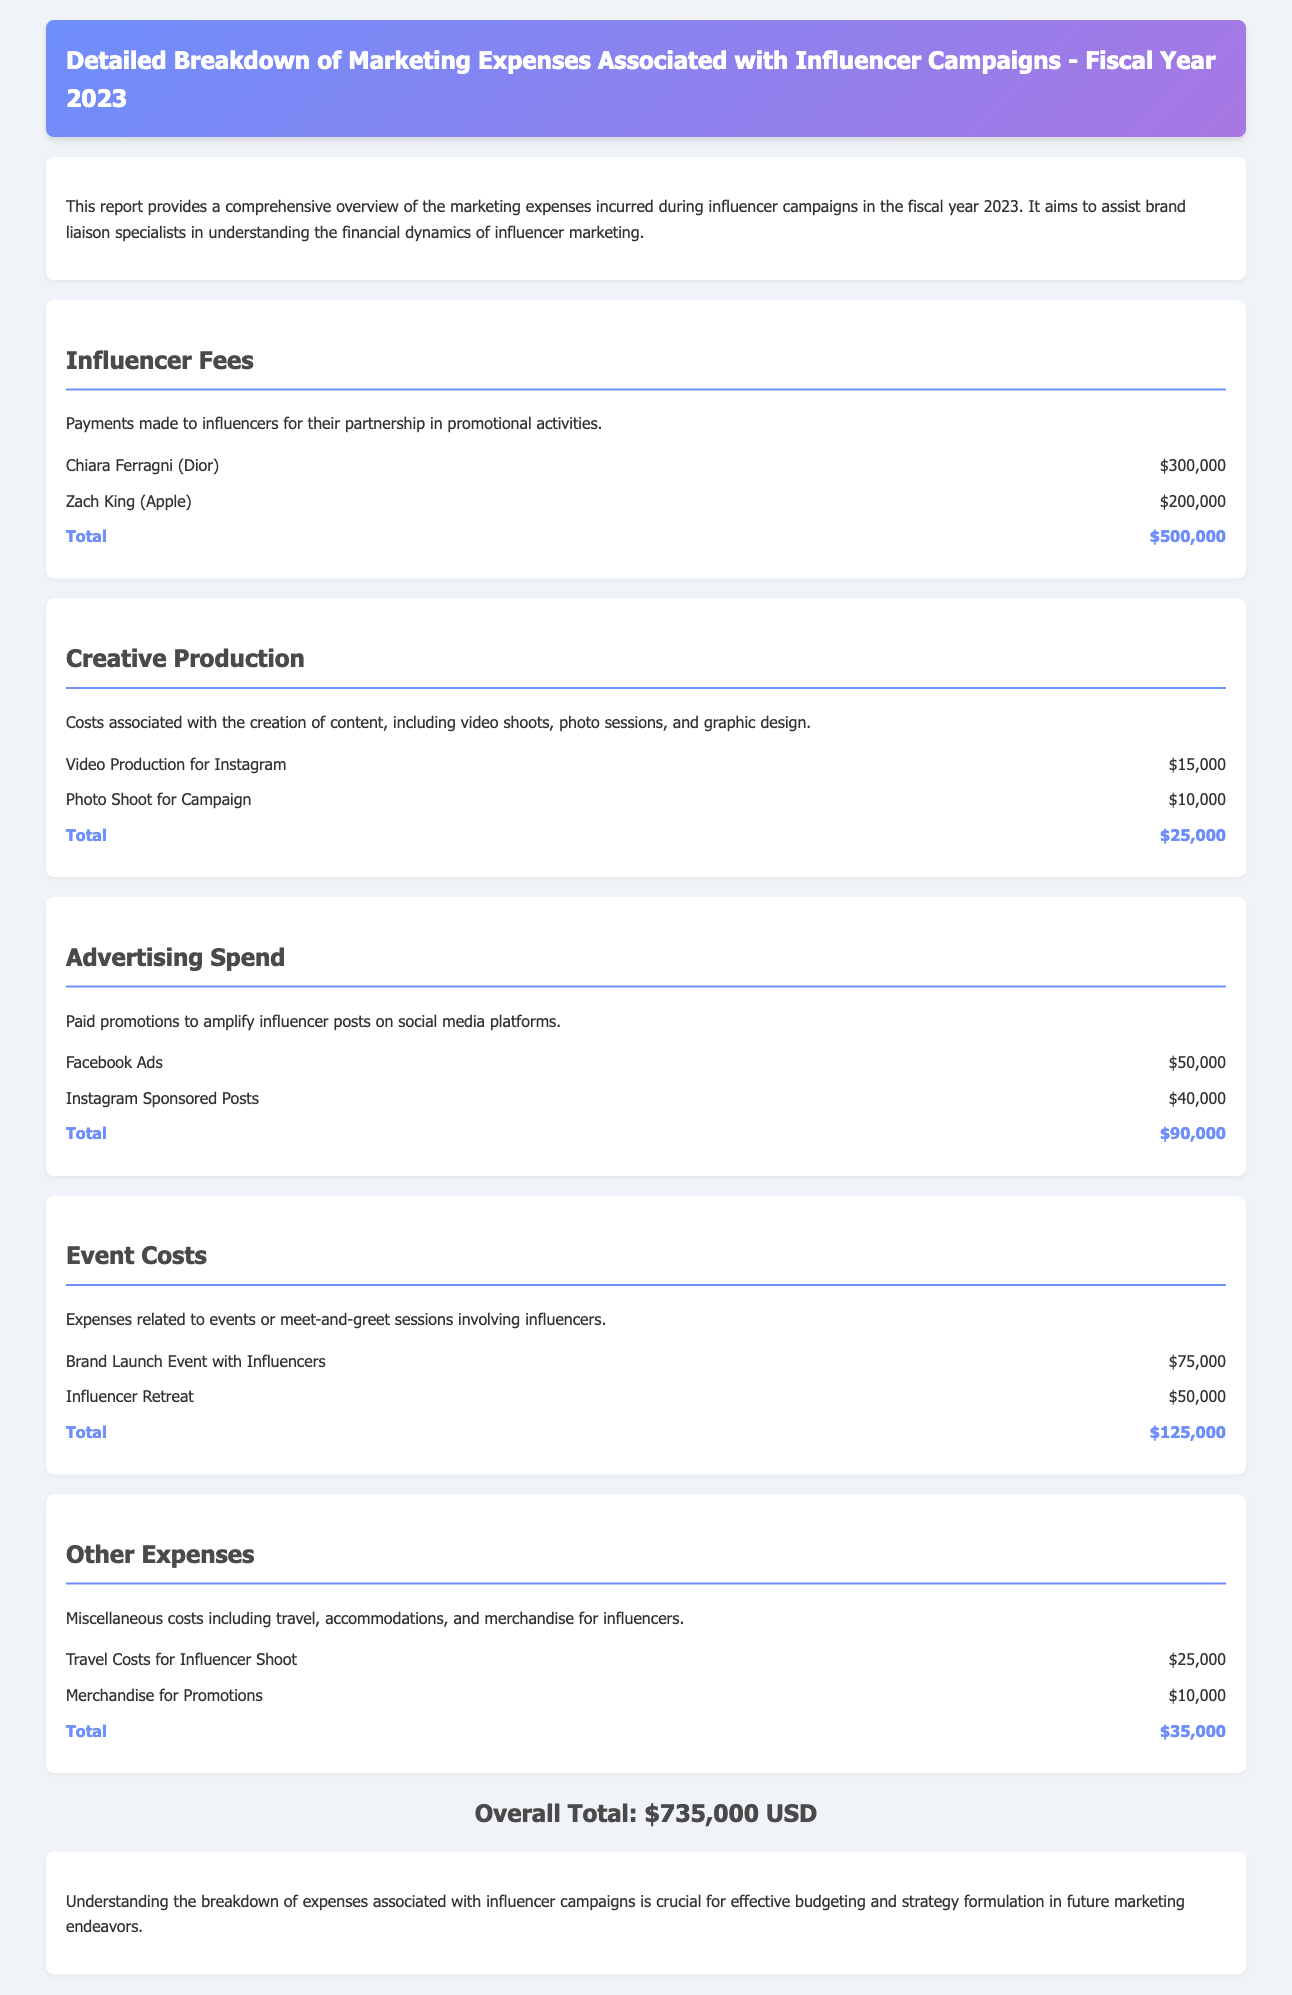What was the total spent on influencer fees? The total spent on influencer fees is the sum of payments made to the influencers listed in the report, which is $300,000 + $200,000.
Answer: $500,000 What were the costs associated with creative production? The costs associated with creative production include video and photo shoot expenses, totaling $15,000 + $10,000.
Answer: $25,000 How much was allocated to advertising spend? The allocated amount for advertising spend includes Facebook Ads and Instagram Sponsored Posts, equating to $50,000 + $40,000.
Answer: $90,000 Which influencer collaborated with Dior? This question seeks the name of the influencer who partnered with Dior mentioned in the report.
Answer: Chiara Ferragni What is the overall total marketing expense for the fiscal year 2023? The overall total marketing expense is calculated from the sum of all expense categories listed in the report.
Answer: $735,000 What was the expense for travel costs associated with influencers? The report specifies the travel costs incurred for influencer campaigns, which is mentioned explicitly.
Answer: $25,000 How much was spent on the brand launch event with influencers? This figure reflects the specific expense mentioned in the event costs section of the report.
Answer: $75,000 Which company did Zach King partner with? The question identifies the brand that Zach King collaborated with, as noted in the influencer fees section.
Answer: Apple What types of expenses are included under "Other Expenses"? This question requires understanding the broader category of miscellaneous expenses listed in the report.
Answer: Travel, accommodations, merchandise 